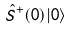Convert formula to latex. <formula><loc_0><loc_0><loc_500><loc_500>\hat { S } ^ { + } ( 0 ) | 0 \rangle</formula> 